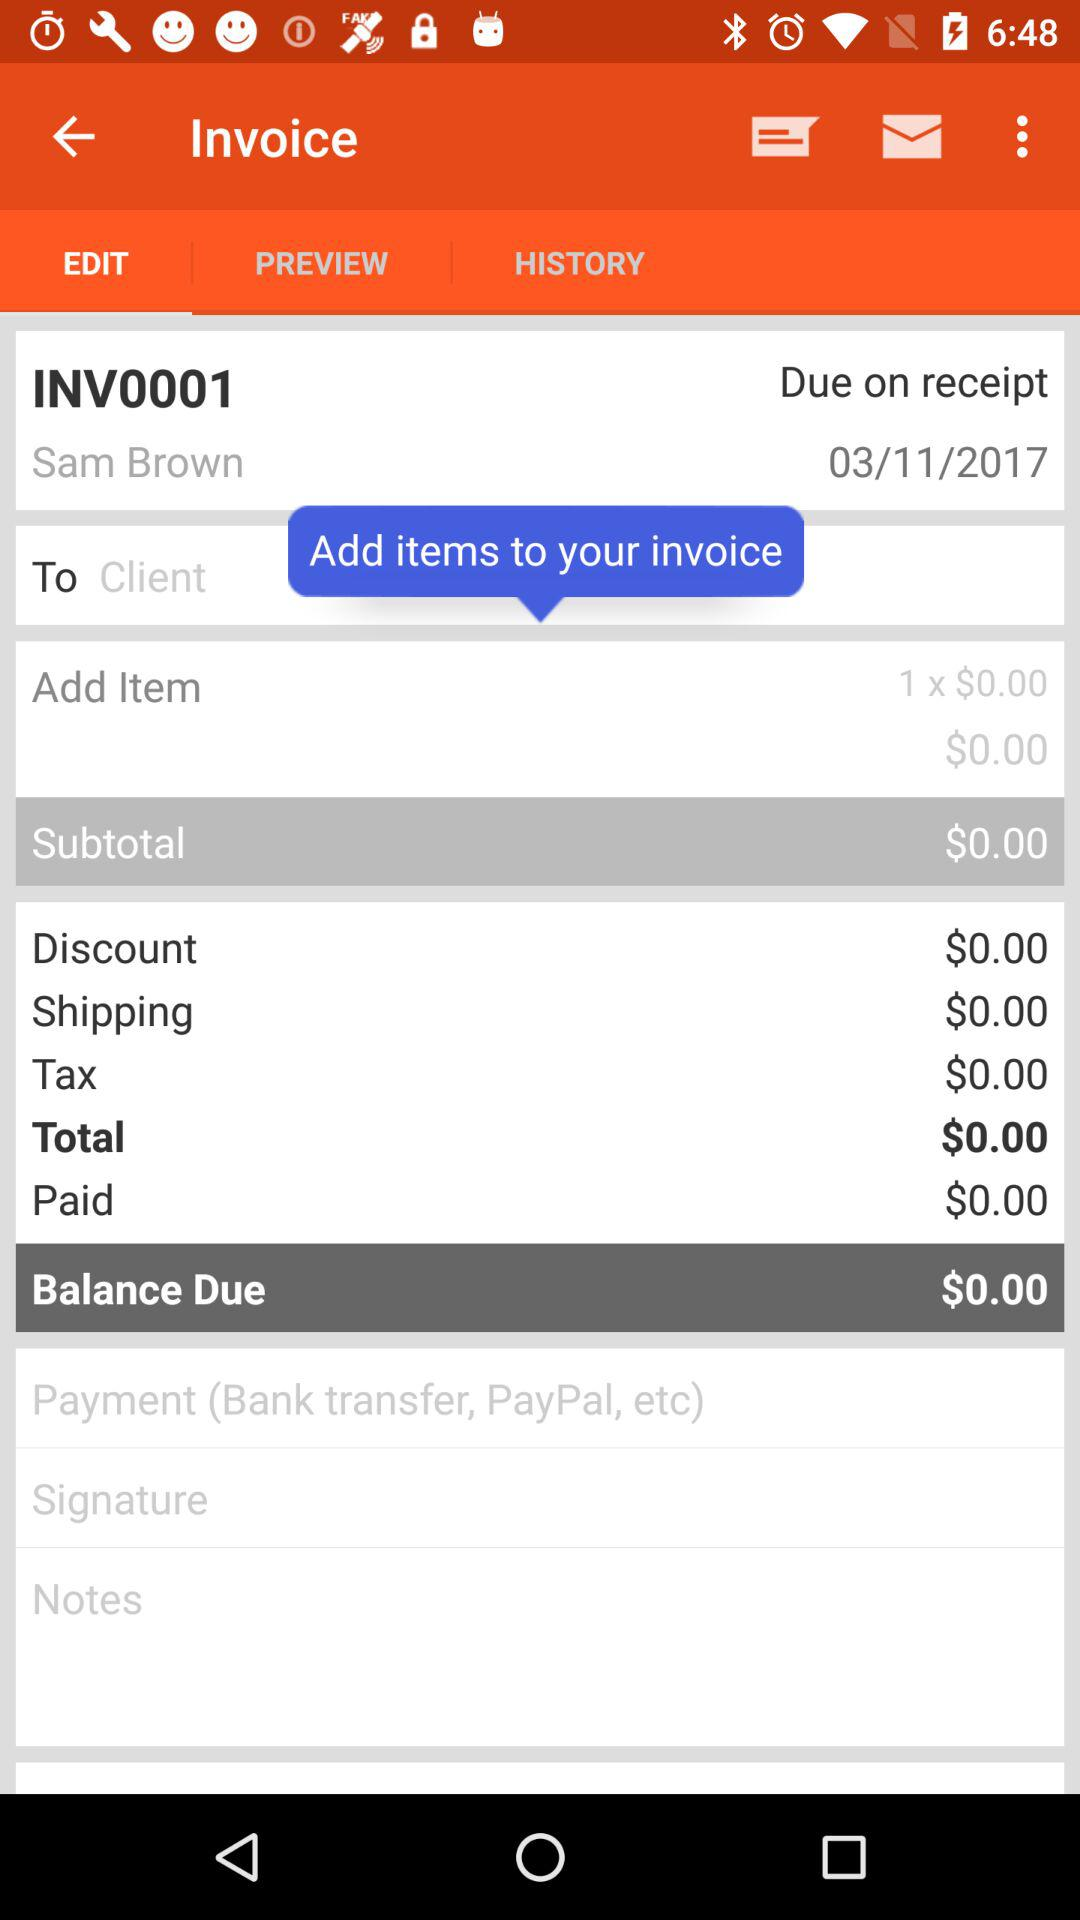What is the shipping cost? The shipping cost is $0.00. 